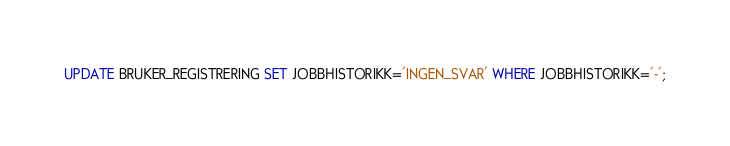Convert code to text. <code><loc_0><loc_0><loc_500><loc_500><_SQL_>UPDATE BRUKER_REGISTRERING SET JOBBHISTORIKK='INGEN_SVAR' WHERE JOBBHISTORIKK='-';</code> 